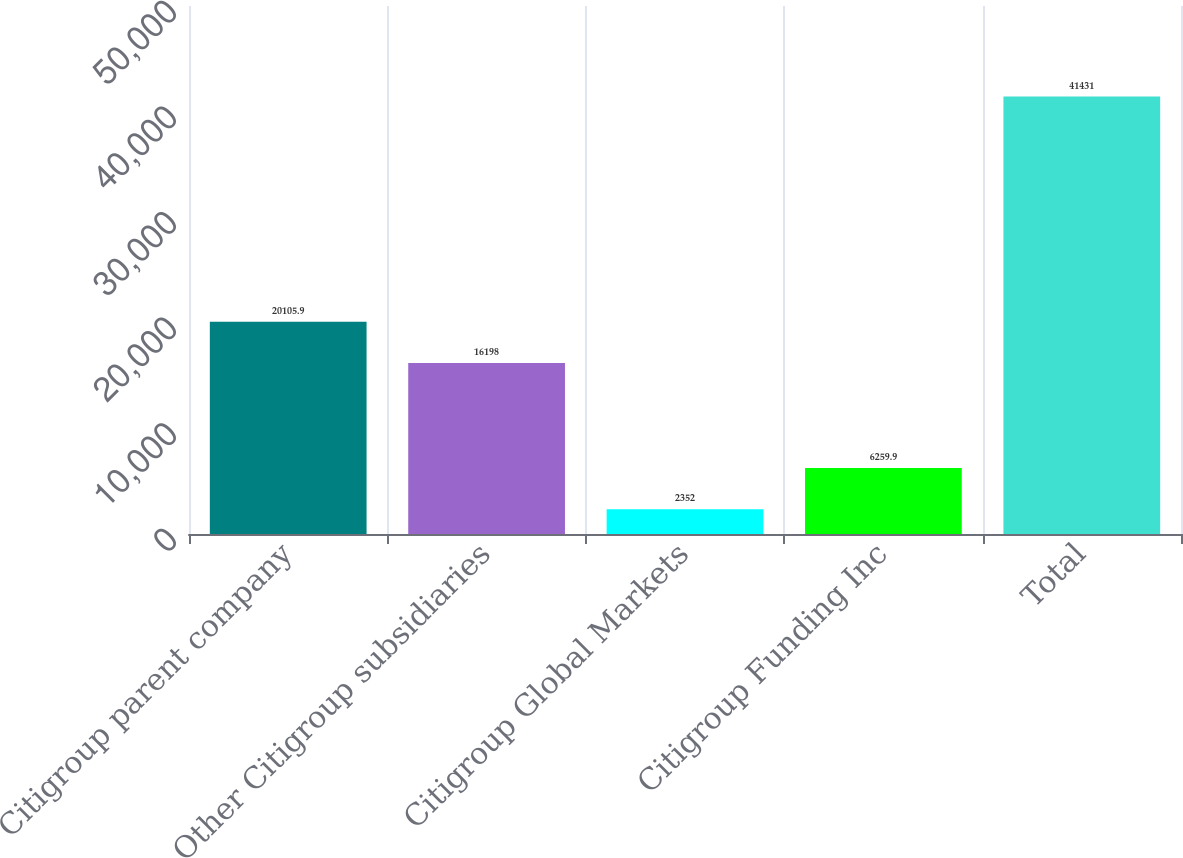<chart> <loc_0><loc_0><loc_500><loc_500><bar_chart><fcel>Citigroup parent company<fcel>Other Citigroup subsidiaries<fcel>Citigroup Global Markets<fcel>Citigroup Funding Inc<fcel>Total<nl><fcel>20105.9<fcel>16198<fcel>2352<fcel>6259.9<fcel>41431<nl></chart> 